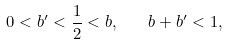<formula> <loc_0><loc_0><loc_500><loc_500>0 < b ^ { \prime } < \frac { 1 } { 2 } < b , \quad b + b ^ { \prime } < 1 ,</formula> 